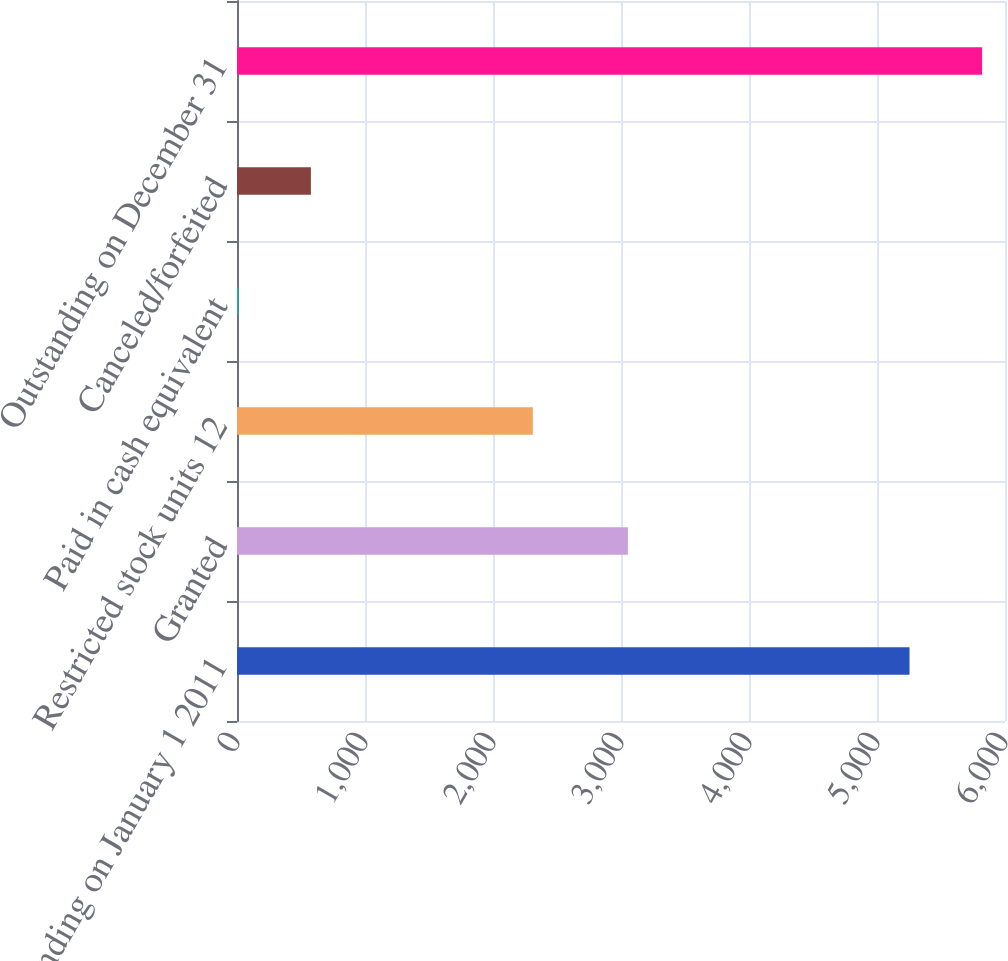Convert chart. <chart><loc_0><loc_0><loc_500><loc_500><bar_chart><fcel>Outstanding on January 1 2011<fcel>Granted<fcel>Restricted stock units 12<fcel>Paid in cash equivalent<fcel>Canceled/forfeited<fcel>Outstanding on December 31<nl><fcel>5254<fcel>3054<fcel>2311<fcel>10<fcel>577.3<fcel>5821.3<nl></chart> 